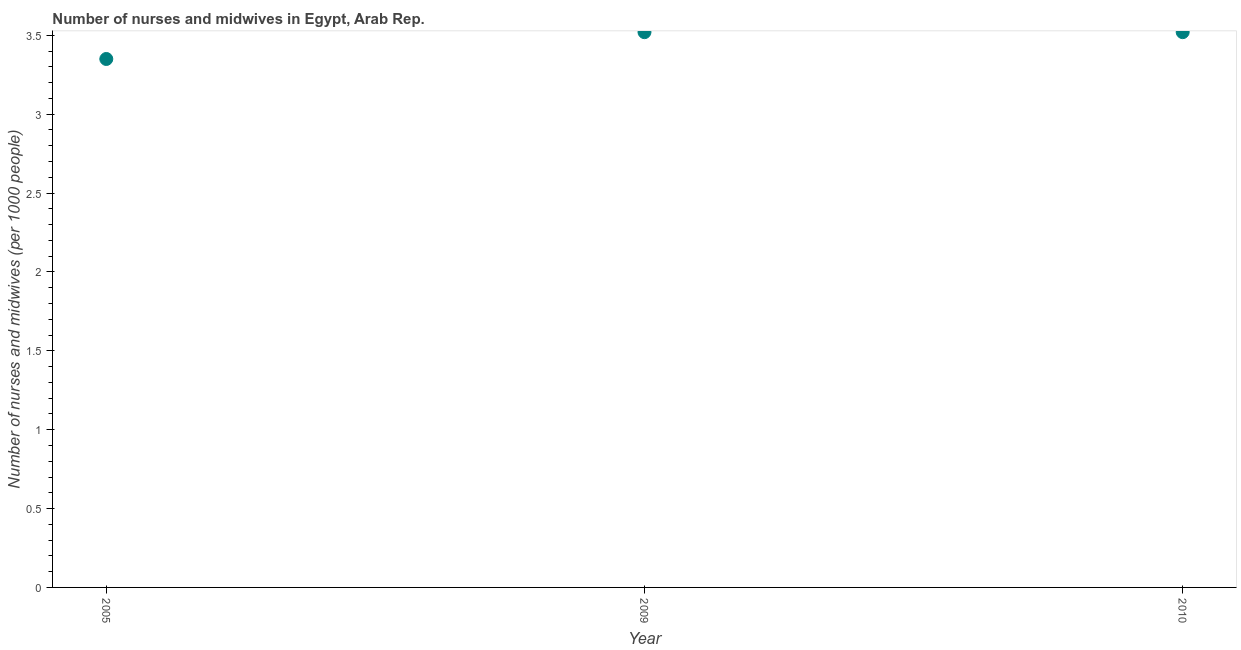What is the number of nurses and midwives in 2010?
Ensure brevity in your answer.  3.52. Across all years, what is the maximum number of nurses and midwives?
Ensure brevity in your answer.  3.52. Across all years, what is the minimum number of nurses and midwives?
Provide a succinct answer. 3.35. What is the sum of the number of nurses and midwives?
Your answer should be compact. 10.39. What is the average number of nurses and midwives per year?
Give a very brief answer. 3.46. What is the median number of nurses and midwives?
Offer a very short reply. 3.52. Do a majority of the years between 2009 and 2010 (inclusive) have number of nurses and midwives greater than 2.7 ?
Provide a succinct answer. Yes. What is the ratio of the number of nurses and midwives in 2009 to that in 2010?
Make the answer very short. 1. Is the number of nurses and midwives in 2009 less than that in 2010?
Ensure brevity in your answer.  No. Is the difference between the number of nurses and midwives in 2005 and 2009 greater than the difference between any two years?
Give a very brief answer. Yes. What is the difference between the highest and the second highest number of nurses and midwives?
Provide a succinct answer. 0. Is the sum of the number of nurses and midwives in 2005 and 2010 greater than the maximum number of nurses and midwives across all years?
Keep it short and to the point. Yes. What is the difference between the highest and the lowest number of nurses and midwives?
Your answer should be compact. 0.17. In how many years, is the number of nurses and midwives greater than the average number of nurses and midwives taken over all years?
Provide a succinct answer. 2. How many years are there in the graph?
Your answer should be very brief. 3. Does the graph contain any zero values?
Ensure brevity in your answer.  No. What is the title of the graph?
Your answer should be very brief. Number of nurses and midwives in Egypt, Arab Rep. What is the label or title of the X-axis?
Your answer should be very brief. Year. What is the label or title of the Y-axis?
Offer a terse response. Number of nurses and midwives (per 1000 people). What is the Number of nurses and midwives (per 1000 people) in 2005?
Your answer should be compact. 3.35. What is the Number of nurses and midwives (per 1000 people) in 2009?
Your answer should be very brief. 3.52. What is the Number of nurses and midwives (per 1000 people) in 2010?
Your answer should be very brief. 3.52. What is the difference between the Number of nurses and midwives (per 1000 people) in 2005 and 2009?
Your answer should be compact. -0.17. What is the difference between the Number of nurses and midwives (per 1000 people) in 2005 and 2010?
Provide a succinct answer. -0.17. What is the ratio of the Number of nurses and midwives (per 1000 people) in 2005 to that in 2010?
Give a very brief answer. 0.95. What is the ratio of the Number of nurses and midwives (per 1000 people) in 2009 to that in 2010?
Your answer should be very brief. 1. 